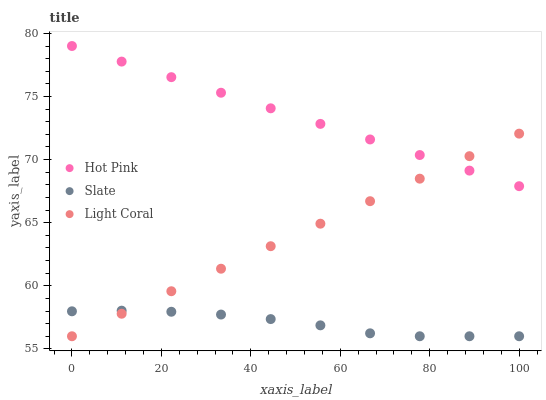Does Slate have the minimum area under the curve?
Answer yes or no. Yes. Does Hot Pink have the maximum area under the curve?
Answer yes or no. Yes. Does Hot Pink have the minimum area under the curve?
Answer yes or no. No. Does Slate have the maximum area under the curve?
Answer yes or no. No. Is Light Coral the smoothest?
Answer yes or no. Yes. Is Slate the roughest?
Answer yes or no. Yes. Is Hot Pink the smoothest?
Answer yes or no. No. Is Hot Pink the roughest?
Answer yes or no. No. Does Light Coral have the lowest value?
Answer yes or no. Yes. Does Hot Pink have the lowest value?
Answer yes or no. No. Does Hot Pink have the highest value?
Answer yes or no. Yes. Does Slate have the highest value?
Answer yes or no. No. Is Slate less than Hot Pink?
Answer yes or no. Yes. Is Hot Pink greater than Slate?
Answer yes or no. Yes. Does Slate intersect Light Coral?
Answer yes or no. Yes. Is Slate less than Light Coral?
Answer yes or no. No. Is Slate greater than Light Coral?
Answer yes or no. No. Does Slate intersect Hot Pink?
Answer yes or no. No. 